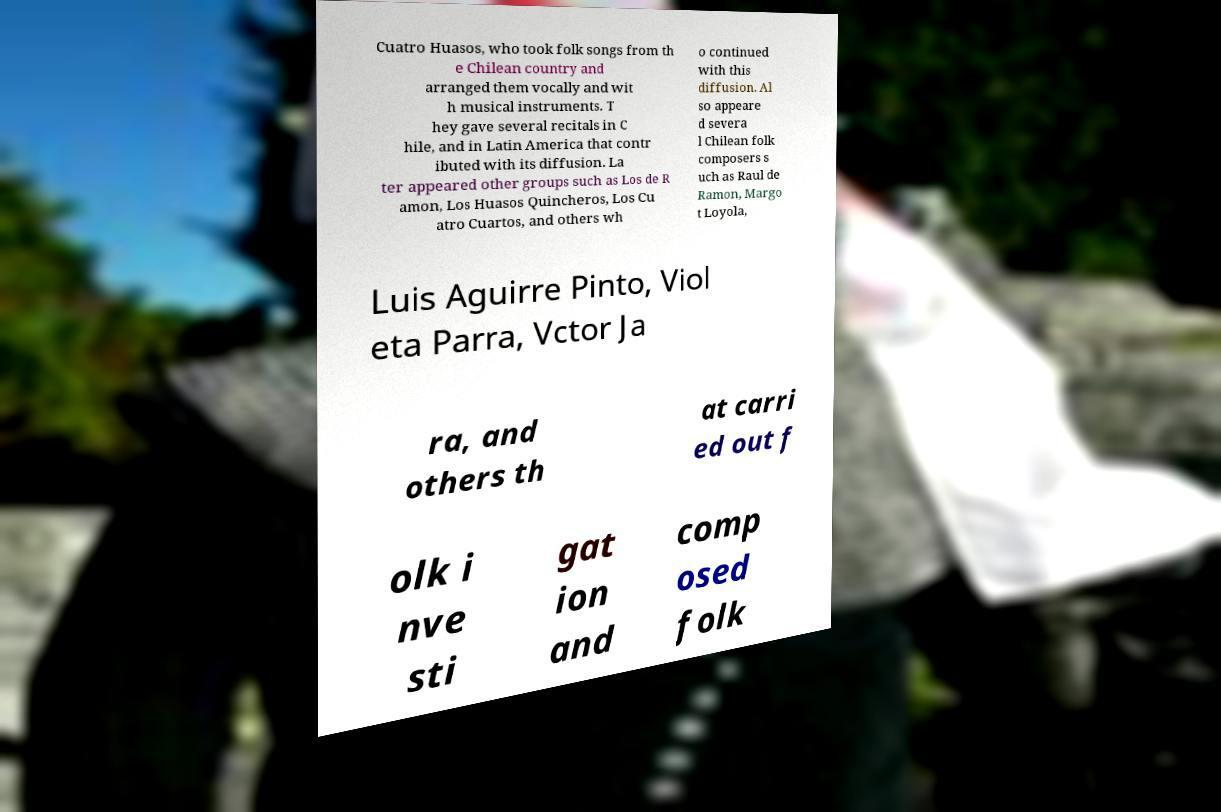Please read and relay the text visible in this image. What does it say? Cuatro Huasos, who took folk songs from th e Chilean country and arranged them vocally and wit h musical instruments. T hey gave several recitals in C hile, and in Latin America that contr ibuted with its diffusion. La ter appeared other groups such as Los de R amon, Los Huasos Quincheros, Los Cu atro Cuartos, and others wh o continued with this diffusion. Al so appeare d severa l Chilean folk composers s uch as Raul de Ramon, Margo t Loyola, Luis Aguirre Pinto, Viol eta Parra, Vctor Ja ra, and others th at carri ed out f olk i nve sti gat ion and comp osed folk 